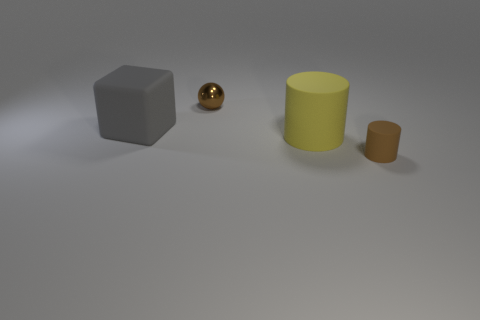Add 4 matte cylinders. How many objects exist? 8 Subtract all balls. How many objects are left? 3 Add 3 large gray blocks. How many large gray blocks are left? 4 Add 4 big rubber cubes. How many big rubber cubes exist? 5 Subtract 0 purple spheres. How many objects are left? 4 Subtract all blocks. Subtract all gray things. How many objects are left? 2 